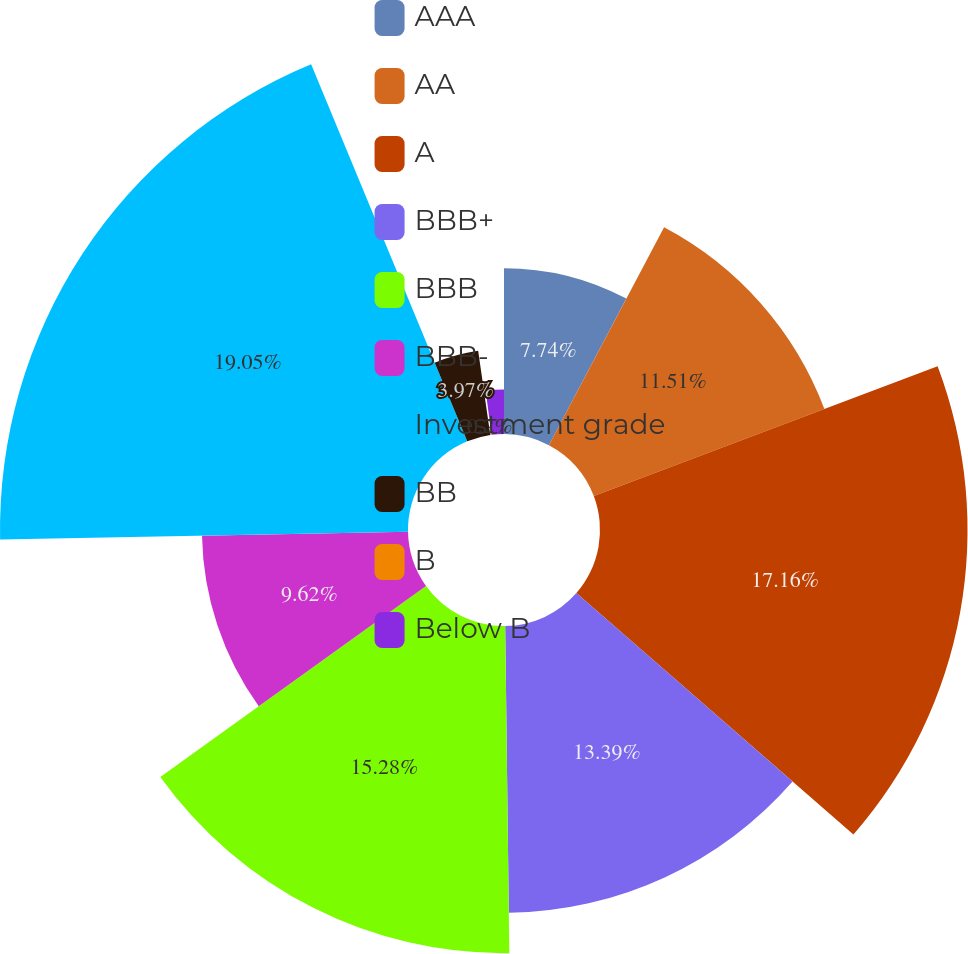<chart> <loc_0><loc_0><loc_500><loc_500><pie_chart><fcel>AAA<fcel>AA<fcel>A<fcel>BBB+<fcel>BBB<fcel>BBB-<fcel>Investment grade<fcel>BB<fcel>B<fcel>Below B<nl><fcel>7.74%<fcel>11.51%<fcel>17.16%<fcel>13.39%<fcel>15.28%<fcel>9.62%<fcel>19.05%<fcel>3.97%<fcel>0.2%<fcel>2.08%<nl></chart> 